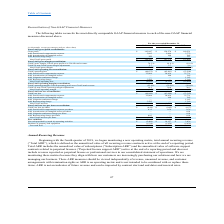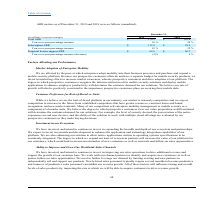According to Mobileiron's financial document, When did the company start monitoring total annual recurring revenue?  Beginning with the fourth quarter of 2018. The document states: "Beginning with the fourth quarter of 2018, we began monitoring a new operating metric, total annual recurring revenue..." Also, What were the values of subscription ARRs for the years 2019 and 2018 respectively? The document shows two values: $113.9 and $95.9 (in millions). From the document: "Subscription ARR $ 113.9 $ 95.9 Subscription ARR $ 113.9 $ 95.9..." Also, What were the values of perpetual license support ARRs for the years 2019 and 2018 respectively? The document shows two values: $65.6 and $66.7 (in millions). From the document: "Perpetual license support ARR $ 65.6 $ 66.7 Perpetual license support ARR $ 65.6 $ 66.7..." Also, can you calculate: What was the average year-over-year percentage increase of total ARRs  from 2018 to 2019? To answer this question, I need to perform calculations using the financial data. The calculation is: (10%+20%)/2, which equals 15 (percentage). This is based on the information: "Add: Amortization of intangible assets — 100 545 (in millions, except percentages) 2019 2018 (in millions, except percentages) 2019 2018..." The key data points involved are: 10, 2, 20. Also, How many years did total ARR exceed $162 million? Counting the relevant items in the document: 2019, 2018, I find 2 instances. The key data points involved are: 2018, 2019. Also, can you calculate: What was the percentage change in the perpetual license support ARR from 2018 to 2019? To answer this question, I need to perform calculations using the financial data. The calculation is: (65.6-66.7)/66.7, which equals -1.65 (percentage). This is based on the information: "Perpetual license support ARR $ 65.6 $ 66.7 Perpetual license support ARR $ 65.6 $ 66.7..." The key data points involved are: 65.6, 66.7. 